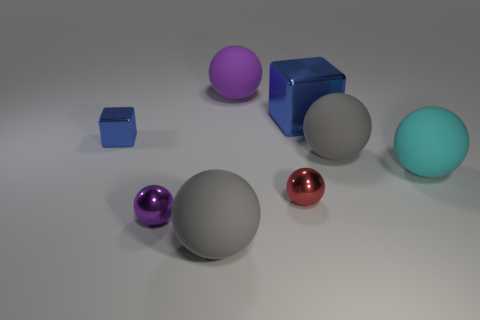Do the block that is to the left of the large purple thing and the metallic block on the right side of the small purple metallic thing have the same color?
Give a very brief answer. Yes. Is the number of large rubber things in front of the cyan rubber object greater than the number of yellow metallic blocks?
Keep it short and to the point. Yes. There is a gray object that is behind the large gray ball in front of the cyan ball; is there a large gray ball that is in front of it?
Give a very brief answer. Yes. There is a red sphere; are there any big purple things in front of it?
Offer a terse response. No. How many tiny things are the same color as the large cube?
Your answer should be very brief. 1. What is the size of the purple thing that is the same material as the red thing?
Give a very brief answer. Small. There is a gray object that is to the right of the blue metallic object right of the large matte ball in front of the cyan thing; what is its size?
Your response must be concise. Large. What size is the purple sphere in front of the tiny blue metal thing?
Your response must be concise. Small. What number of purple objects are blocks or metallic balls?
Offer a very short reply. 1. Are there any blue blocks that have the same size as the cyan rubber thing?
Give a very brief answer. Yes. 